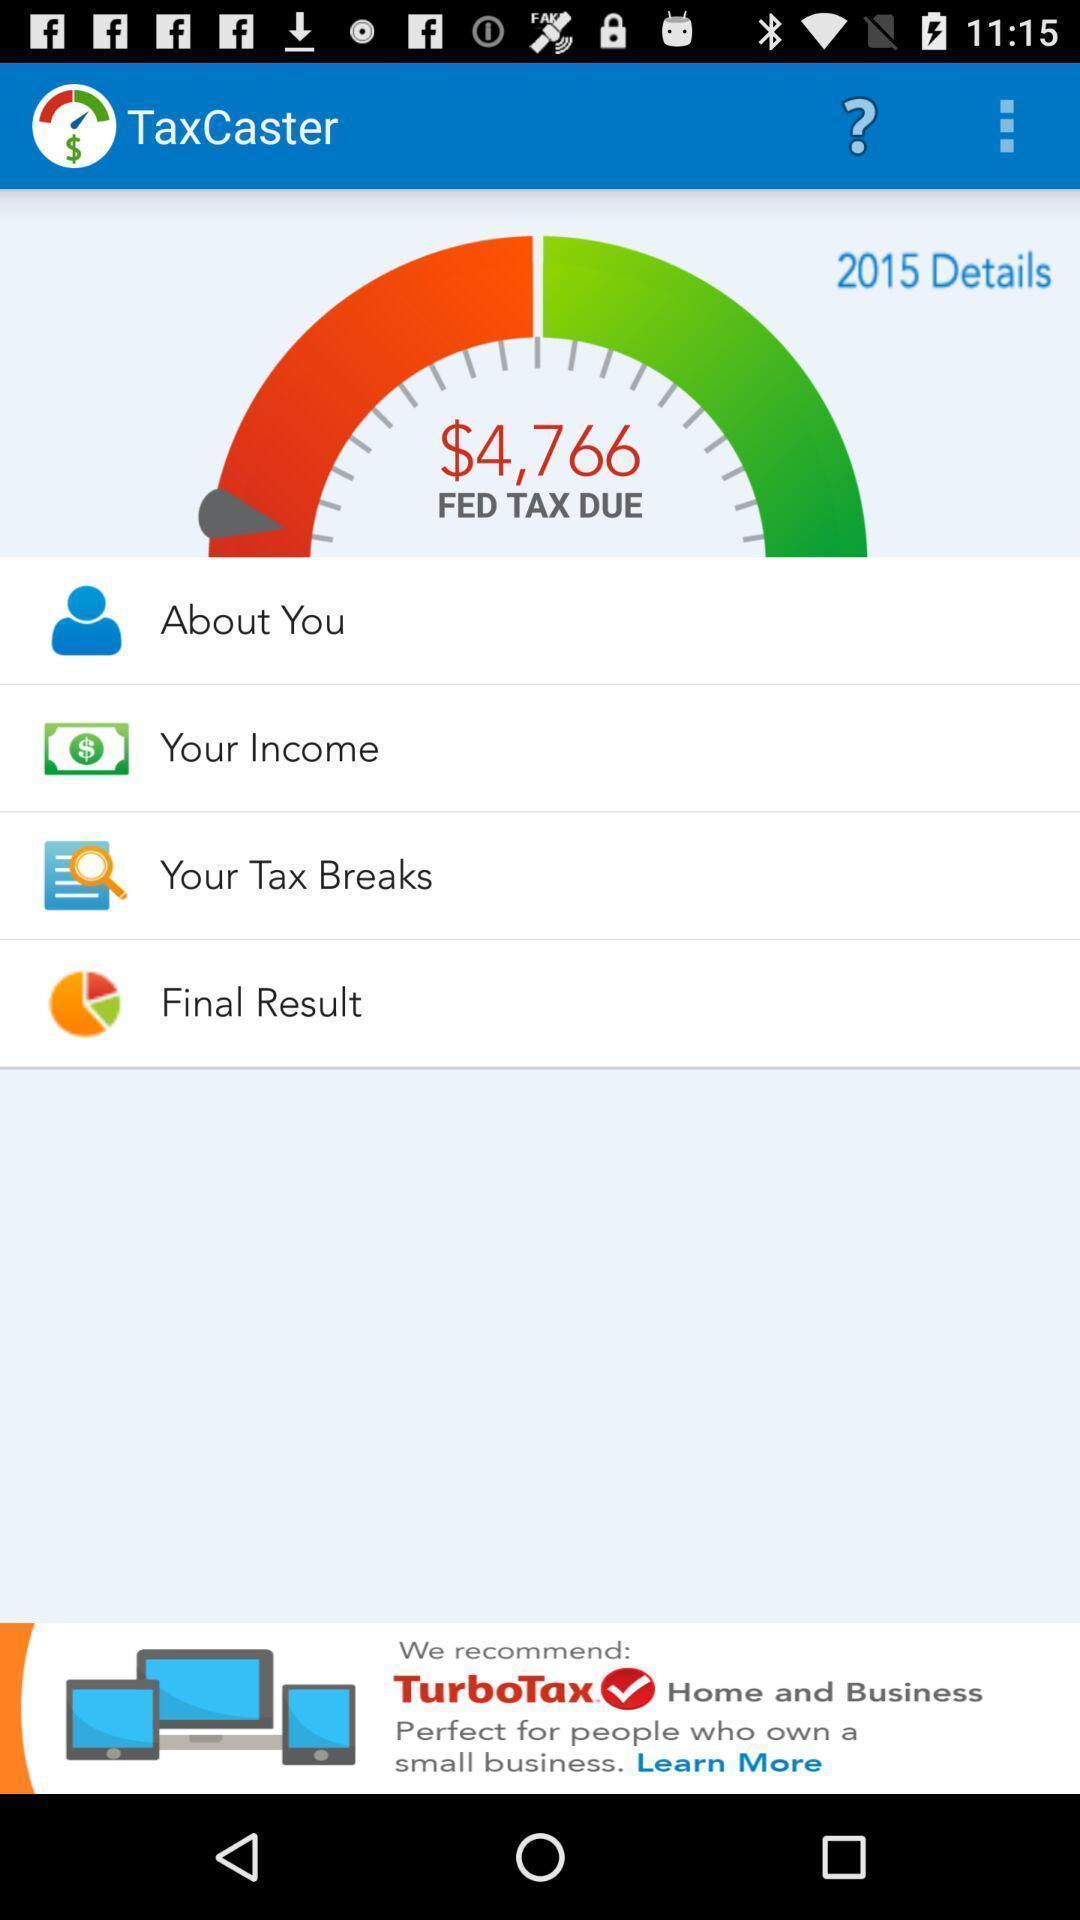Describe the visual elements of this screenshot. Page showing feb tax due with options. 